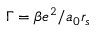Convert formula to latex. <formula><loc_0><loc_0><loc_500><loc_500>\Gamma = \beta e ^ { 2 } / a _ { 0 } r _ { s }</formula> 